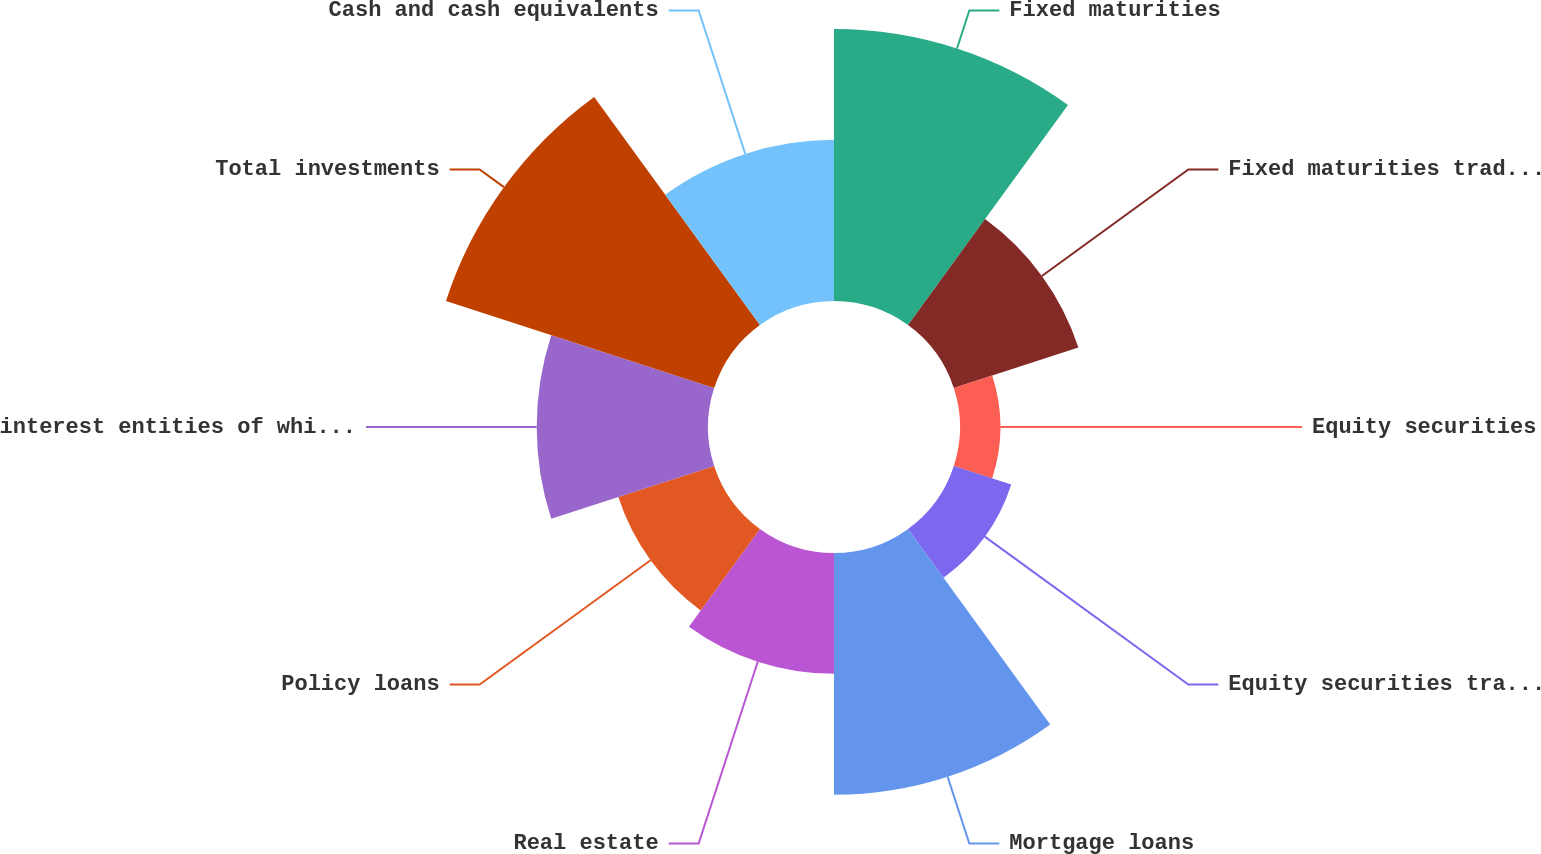Convert chart to OTSL. <chart><loc_0><loc_0><loc_500><loc_500><pie_chart><fcel>Fixed maturities<fcel>Fixed maturities trading (2011<fcel>Equity securities<fcel>Equity securities trading<fcel>Mortgage loans<fcel>Real estate<fcel>Policy loans<fcel>interest entities of which 975<fcel>Total investments<fcel>Cash and cash equivalents<nl><fcel>17.2%<fcel>8.28%<fcel>2.55%<fcel>3.82%<fcel>15.29%<fcel>7.64%<fcel>6.37%<fcel>10.83%<fcel>17.83%<fcel>10.19%<nl></chart> 